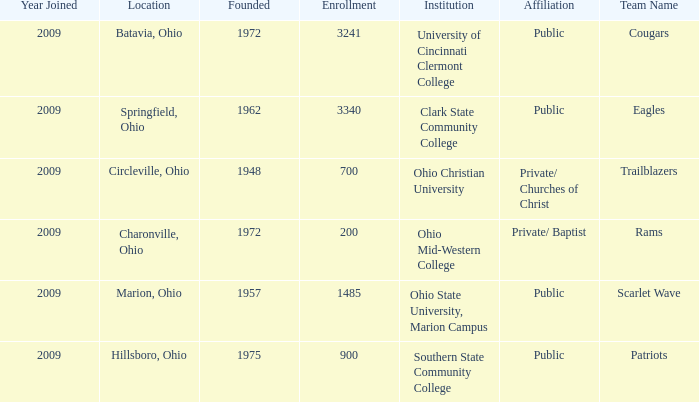What was the location for the team name of patriots? Hillsboro, Ohio. 